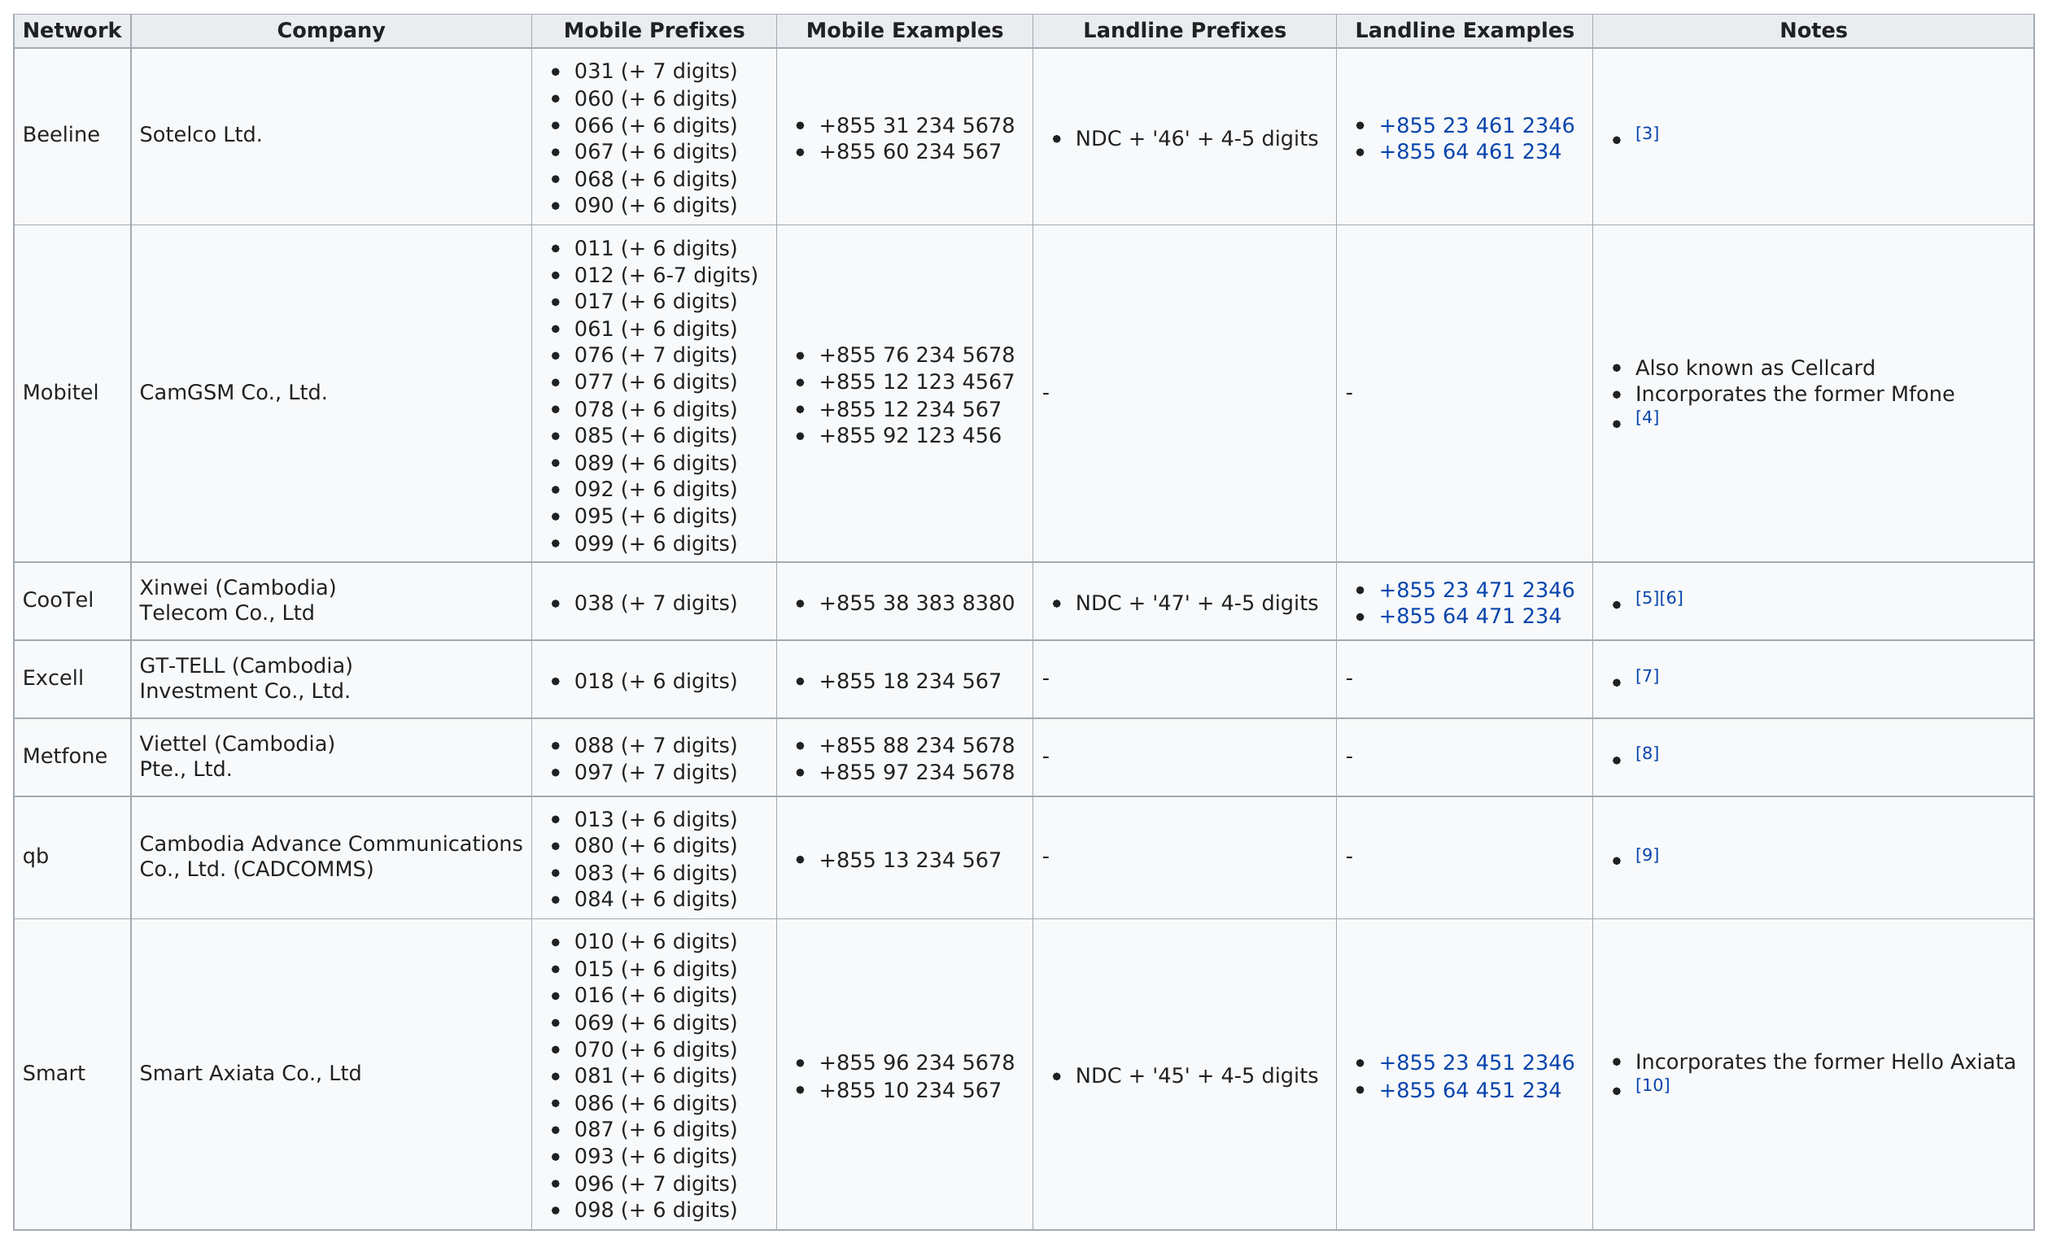Give some essential details in this illustration. Four consecutive companies had no notes listed. Of the networks we have analyzed, four have more than three different mobile Internet prefixes. Mobitel is the only network that is also known as "cellcard. There are eleven prefixes that incorporate the word "hell" in the phrase "Hell Axiata. Beeline and Mobitel have a combined total of 1 landline prefix. 